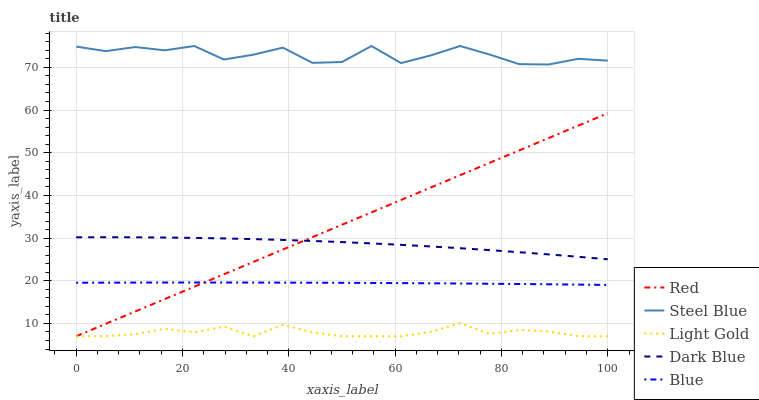Does Light Gold have the minimum area under the curve?
Answer yes or no. Yes. Does Steel Blue have the maximum area under the curve?
Answer yes or no. Yes. Does Dark Blue have the minimum area under the curve?
Answer yes or no. No. Does Dark Blue have the maximum area under the curve?
Answer yes or no. No. Is Red the smoothest?
Answer yes or no. Yes. Is Steel Blue the roughest?
Answer yes or no. Yes. Is Dark Blue the smoothest?
Answer yes or no. No. Is Dark Blue the roughest?
Answer yes or no. No. Does Light Gold have the lowest value?
Answer yes or no. Yes. Does Dark Blue have the lowest value?
Answer yes or no. No. Does Steel Blue have the highest value?
Answer yes or no. Yes. Does Dark Blue have the highest value?
Answer yes or no. No. Is Light Gold less than Blue?
Answer yes or no. Yes. Is Dark Blue greater than Light Gold?
Answer yes or no. Yes. Does Red intersect Blue?
Answer yes or no. Yes. Is Red less than Blue?
Answer yes or no. No. Is Red greater than Blue?
Answer yes or no. No. Does Light Gold intersect Blue?
Answer yes or no. No. 